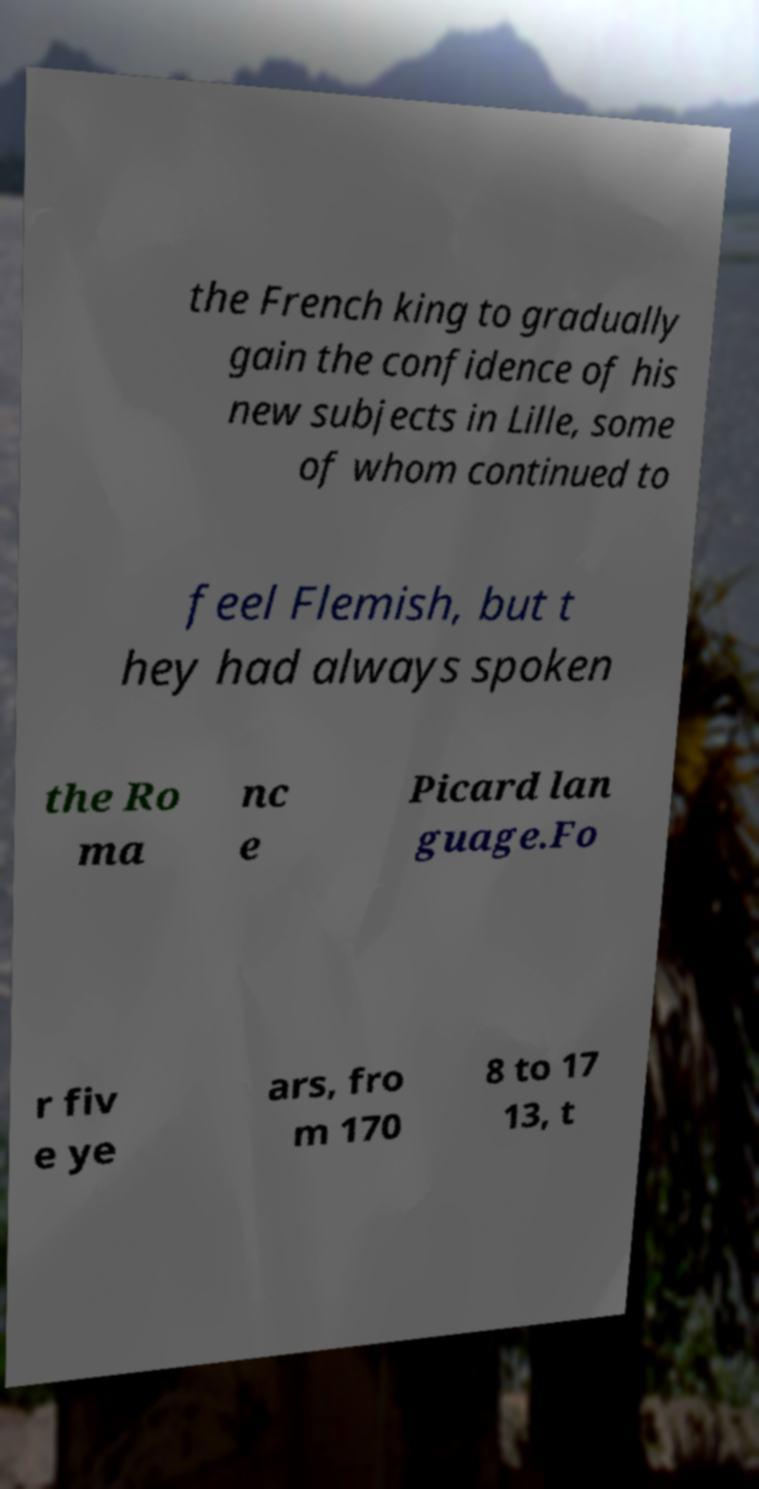Can you accurately transcribe the text from the provided image for me? the French king to gradually gain the confidence of his new subjects in Lille, some of whom continued to feel Flemish, but t hey had always spoken the Ro ma nc e Picard lan guage.Fo r fiv e ye ars, fro m 170 8 to 17 13, t 